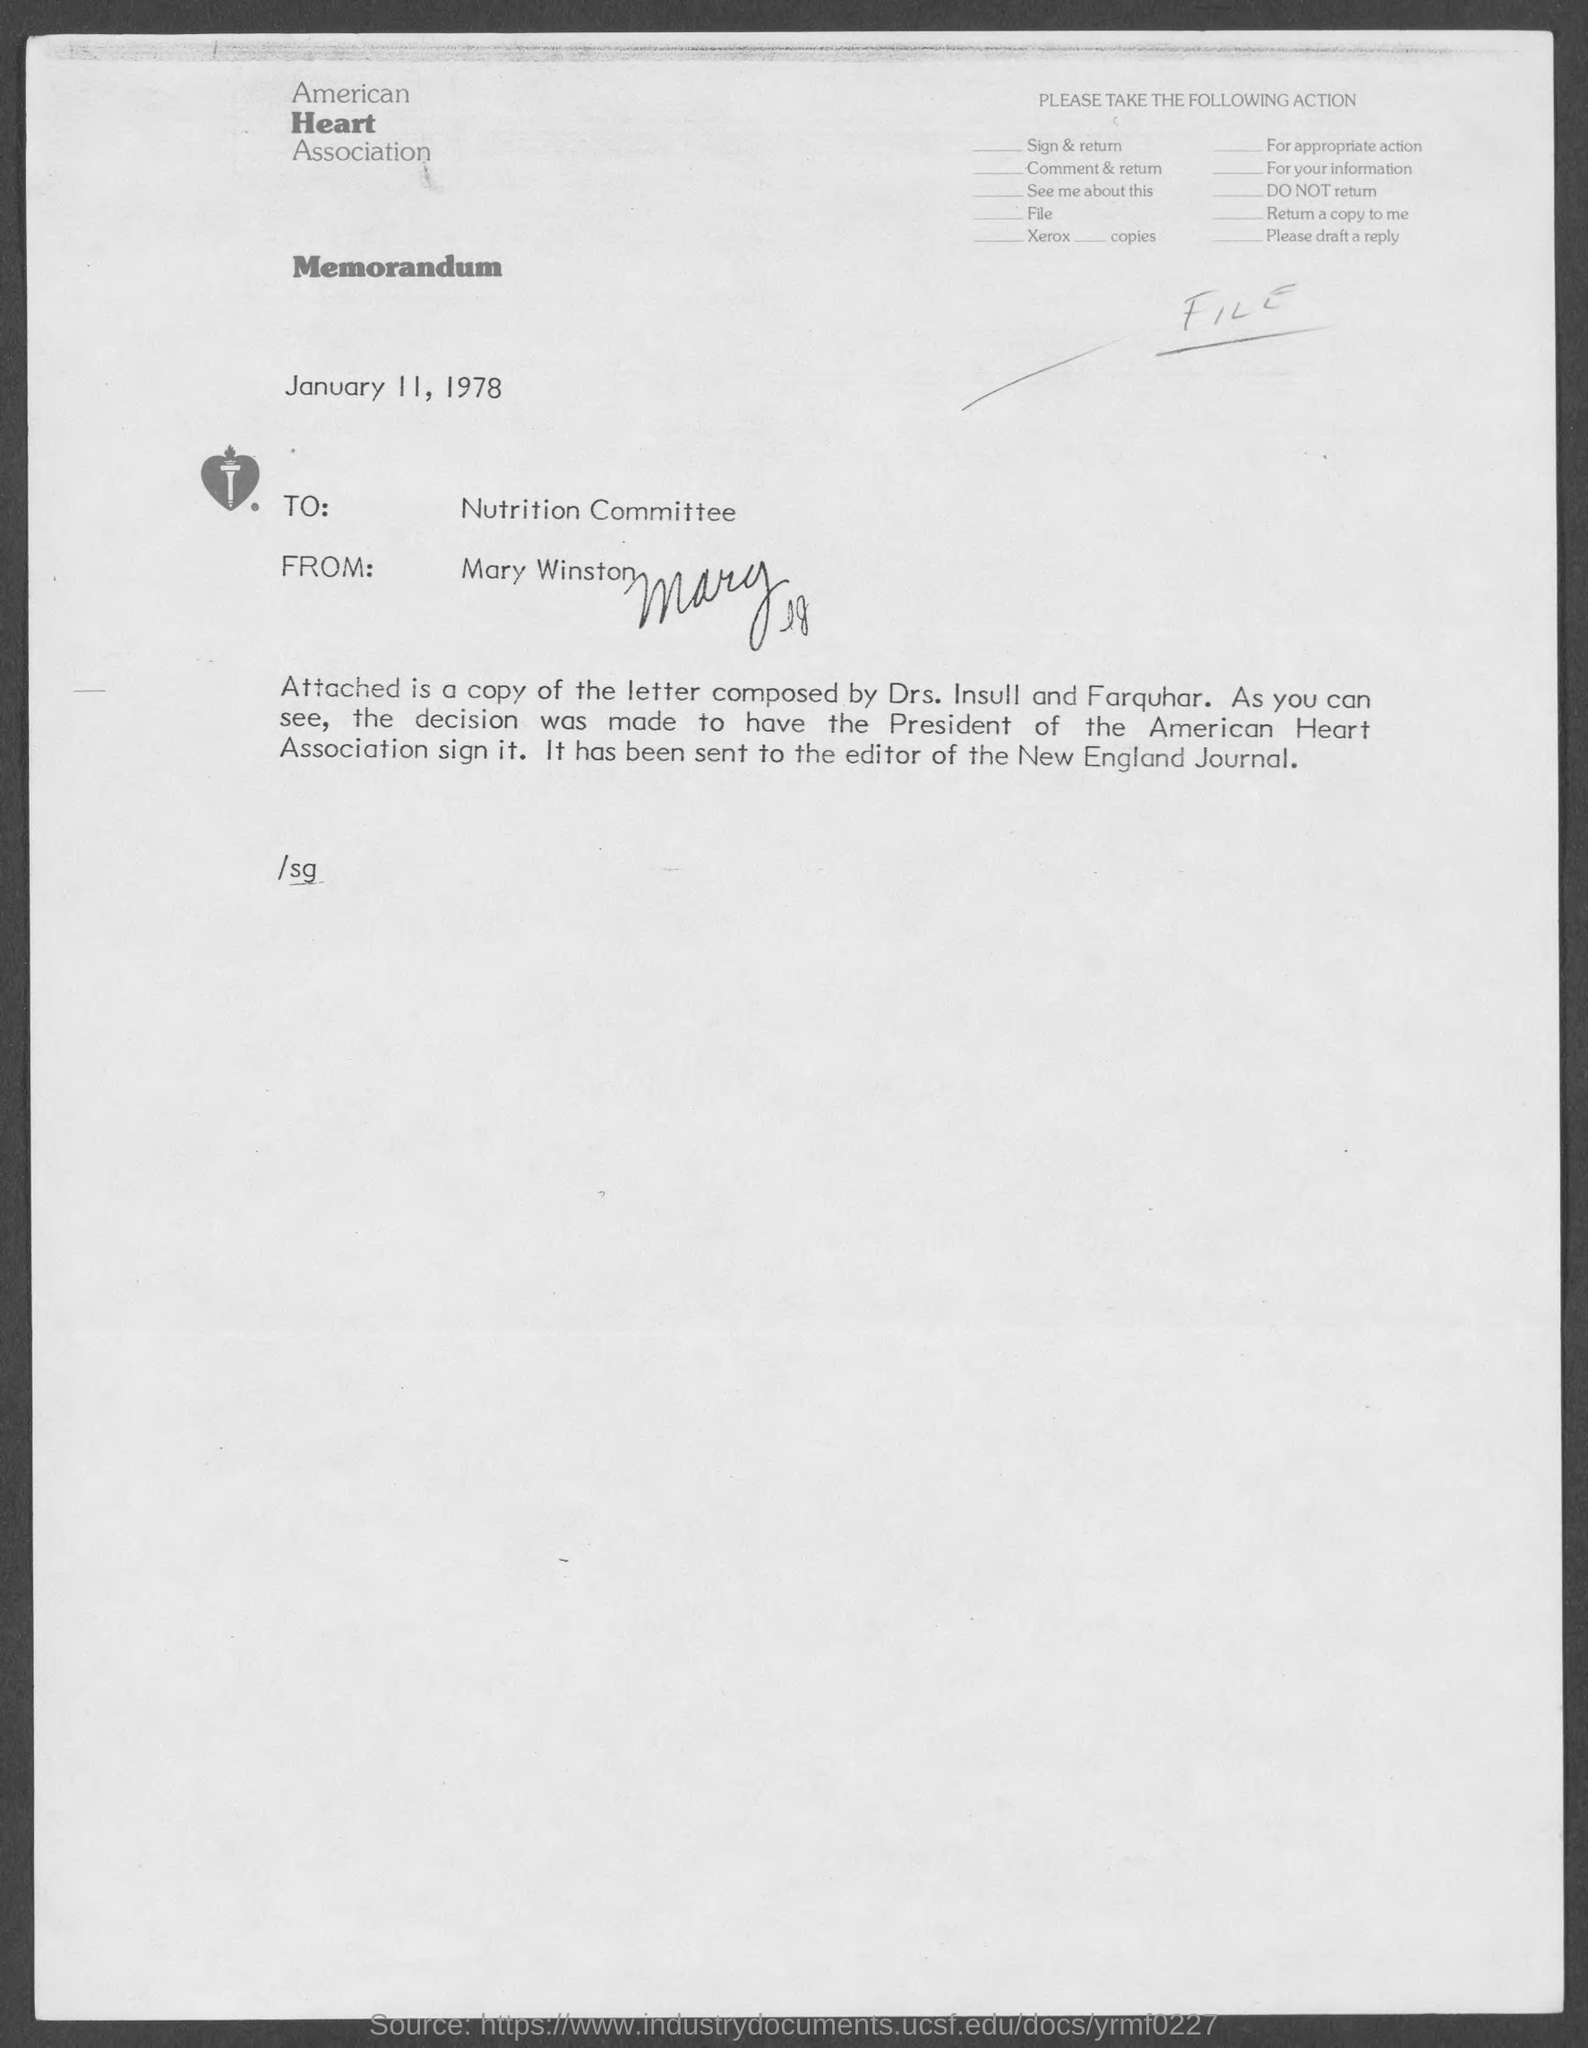Identify some key points in this picture. This memorandum is addressed to the Nutrition Committee. The memorandum is from Mary Winston. The memorandum is dated January 11, 1978. The American Heart Association is the name of the organization at the top of the page. 